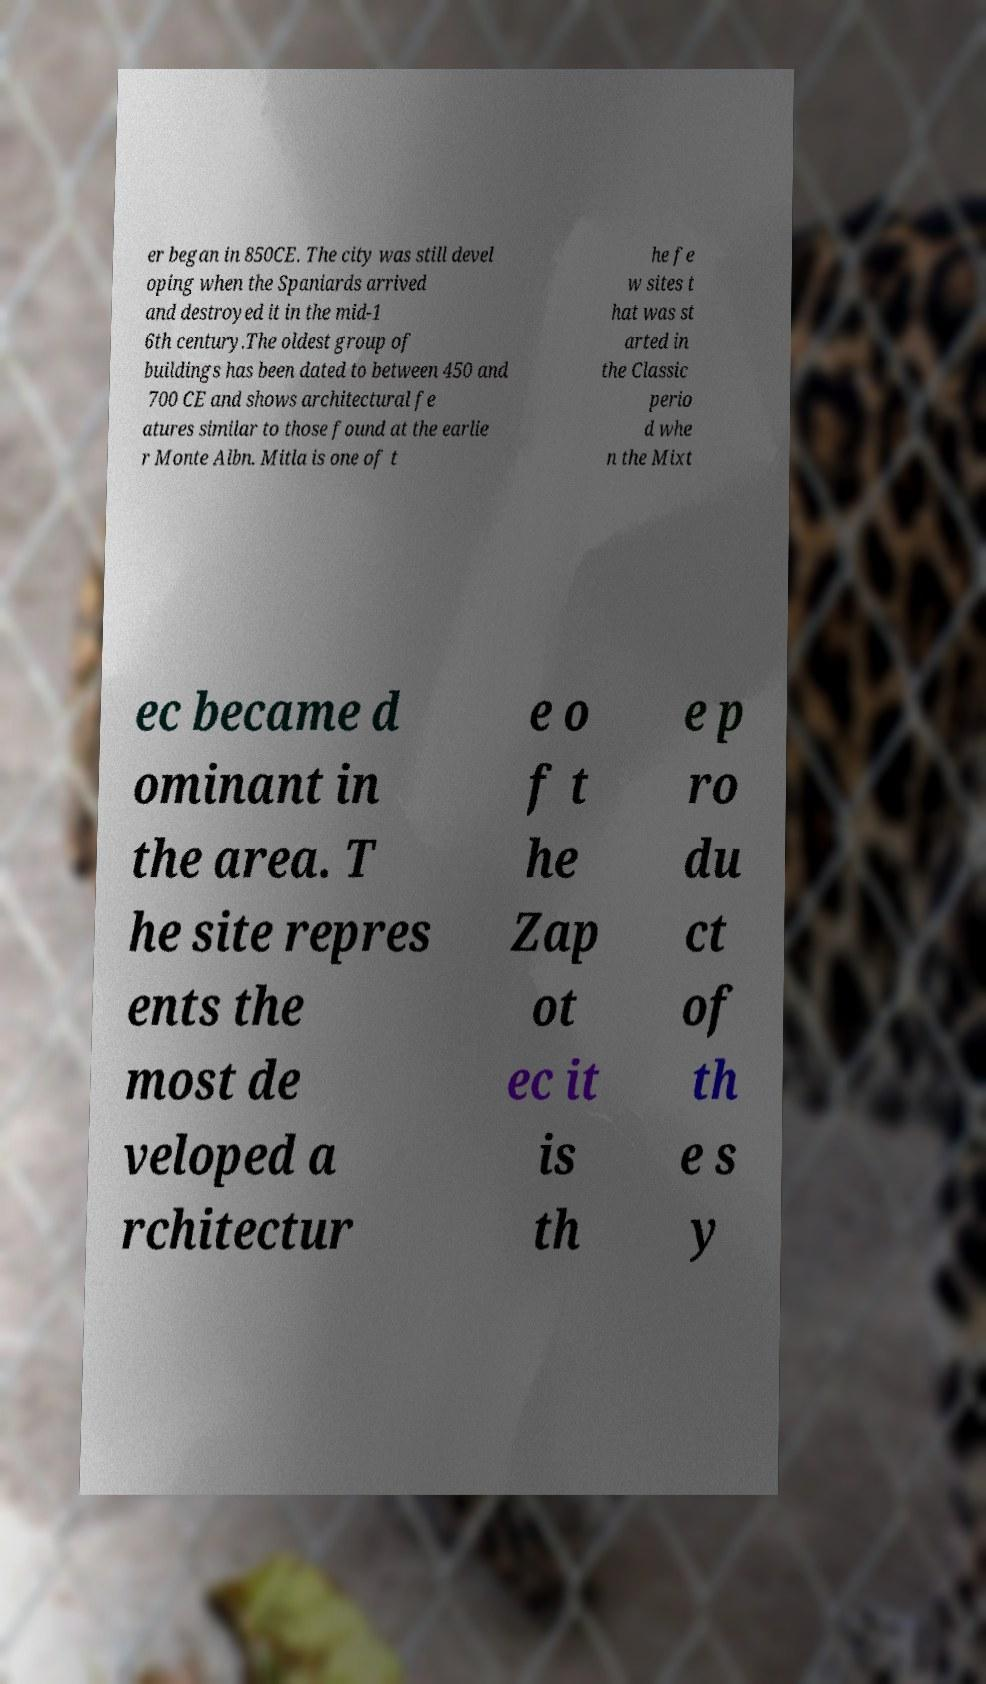For documentation purposes, I need the text within this image transcribed. Could you provide that? er began in 850CE. The city was still devel oping when the Spaniards arrived and destroyed it in the mid-1 6th century.The oldest group of buildings has been dated to between 450 and 700 CE and shows architectural fe atures similar to those found at the earlie r Monte Albn. Mitla is one of t he fe w sites t hat was st arted in the Classic perio d whe n the Mixt ec became d ominant in the area. T he site repres ents the most de veloped a rchitectur e o f t he Zap ot ec it is th e p ro du ct of th e s y 